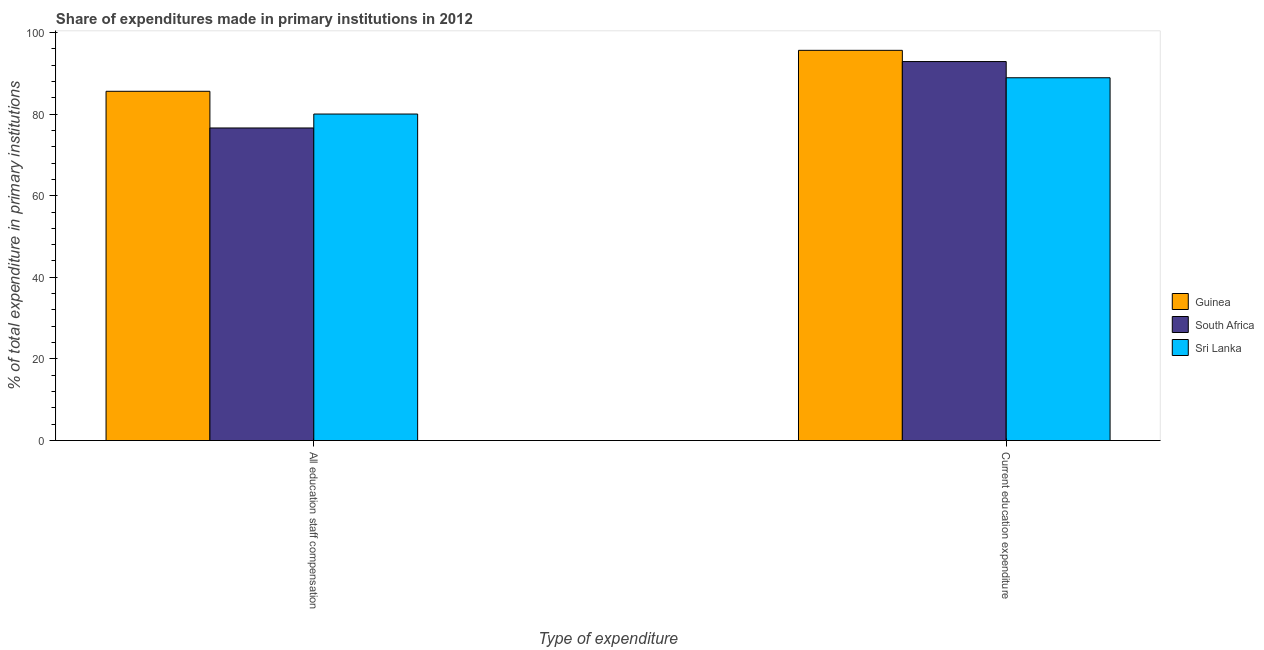How many different coloured bars are there?
Your answer should be very brief. 3. How many bars are there on the 2nd tick from the left?
Your answer should be compact. 3. What is the label of the 1st group of bars from the left?
Provide a succinct answer. All education staff compensation. What is the expenditure in education in Guinea?
Your answer should be compact. 95.61. Across all countries, what is the maximum expenditure in staff compensation?
Keep it short and to the point. 85.58. Across all countries, what is the minimum expenditure in education?
Provide a short and direct response. 88.89. In which country was the expenditure in education maximum?
Ensure brevity in your answer.  Guinea. In which country was the expenditure in staff compensation minimum?
Provide a short and direct response. South Africa. What is the total expenditure in education in the graph?
Your answer should be very brief. 277.37. What is the difference between the expenditure in staff compensation in Sri Lanka and that in Guinea?
Offer a terse response. -5.57. What is the difference between the expenditure in education in South Africa and the expenditure in staff compensation in Guinea?
Provide a succinct answer. 7.29. What is the average expenditure in staff compensation per country?
Make the answer very short. 80.72. What is the difference between the expenditure in staff compensation and expenditure in education in Sri Lanka?
Ensure brevity in your answer.  -8.89. What is the ratio of the expenditure in education in Sri Lanka to that in South Africa?
Keep it short and to the point. 0.96. Is the expenditure in staff compensation in Guinea less than that in South Africa?
Your answer should be compact. No. In how many countries, is the expenditure in staff compensation greater than the average expenditure in staff compensation taken over all countries?
Provide a short and direct response. 1. What does the 2nd bar from the left in Current education expenditure represents?
Offer a very short reply. South Africa. What does the 2nd bar from the right in Current education expenditure represents?
Your response must be concise. South Africa. How many countries are there in the graph?
Give a very brief answer. 3. Does the graph contain grids?
Your answer should be compact. No. How are the legend labels stacked?
Keep it short and to the point. Vertical. What is the title of the graph?
Ensure brevity in your answer.  Share of expenditures made in primary institutions in 2012. What is the label or title of the X-axis?
Your response must be concise. Type of expenditure. What is the label or title of the Y-axis?
Your answer should be compact. % of total expenditure in primary institutions. What is the % of total expenditure in primary institutions of Guinea in All education staff compensation?
Keep it short and to the point. 85.58. What is the % of total expenditure in primary institutions of South Africa in All education staff compensation?
Make the answer very short. 76.59. What is the % of total expenditure in primary institutions of Sri Lanka in All education staff compensation?
Provide a short and direct response. 80. What is the % of total expenditure in primary institutions of Guinea in Current education expenditure?
Keep it short and to the point. 95.61. What is the % of total expenditure in primary institutions of South Africa in Current education expenditure?
Your answer should be very brief. 92.86. What is the % of total expenditure in primary institutions of Sri Lanka in Current education expenditure?
Give a very brief answer. 88.89. Across all Type of expenditure, what is the maximum % of total expenditure in primary institutions of Guinea?
Provide a short and direct response. 95.61. Across all Type of expenditure, what is the maximum % of total expenditure in primary institutions of South Africa?
Keep it short and to the point. 92.86. Across all Type of expenditure, what is the maximum % of total expenditure in primary institutions in Sri Lanka?
Offer a very short reply. 88.89. Across all Type of expenditure, what is the minimum % of total expenditure in primary institutions in Guinea?
Give a very brief answer. 85.58. Across all Type of expenditure, what is the minimum % of total expenditure in primary institutions in South Africa?
Offer a terse response. 76.59. Across all Type of expenditure, what is the minimum % of total expenditure in primary institutions in Sri Lanka?
Provide a short and direct response. 80. What is the total % of total expenditure in primary institutions in Guinea in the graph?
Your answer should be very brief. 181.19. What is the total % of total expenditure in primary institutions in South Africa in the graph?
Ensure brevity in your answer.  169.45. What is the total % of total expenditure in primary institutions of Sri Lanka in the graph?
Ensure brevity in your answer.  168.9. What is the difference between the % of total expenditure in primary institutions of Guinea in All education staff compensation and that in Current education expenditure?
Your response must be concise. -10.04. What is the difference between the % of total expenditure in primary institutions of South Africa in All education staff compensation and that in Current education expenditure?
Make the answer very short. -16.27. What is the difference between the % of total expenditure in primary institutions of Sri Lanka in All education staff compensation and that in Current education expenditure?
Your response must be concise. -8.89. What is the difference between the % of total expenditure in primary institutions in Guinea in All education staff compensation and the % of total expenditure in primary institutions in South Africa in Current education expenditure?
Your answer should be compact. -7.29. What is the difference between the % of total expenditure in primary institutions in Guinea in All education staff compensation and the % of total expenditure in primary institutions in Sri Lanka in Current education expenditure?
Keep it short and to the point. -3.31. What is the difference between the % of total expenditure in primary institutions of South Africa in All education staff compensation and the % of total expenditure in primary institutions of Sri Lanka in Current education expenditure?
Your answer should be compact. -12.3. What is the average % of total expenditure in primary institutions of Guinea per Type of expenditure?
Ensure brevity in your answer.  90.6. What is the average % of total expenditure in primary institutions of South Africa per Type of expenditure?
Ensure brevity in your answer.  84.73. What is the average % of total expenditure in primary institutions of Sri Lanka per Type of expenditure?
Provide a short and direct response. 84.45. What is the difference between the % of total expenditure in primary institutions of Guinea and % of total expenditure in primary institutions of South Africa in All education staff compensation?
Your answer should be very brief. 8.99. What is the difference between the % of total expenditure in primary institutions in Guinea and % of total expenditure in primary institutions in Sri Lanka in All education staff compensation?
Give a very brief answer. 5.57. What is the difference between the % of total expenditure in primary institutions of South Africa and % of total expenditure in primary institutions of Sri Lanka in All education staff compensation?
Your answer should be very brief. -3.41. What is the difference between the % of total expenditure in primary institutions of Guinea and % of total expenditure in primary institutions of South Africa in Current education expenditure?
Provide a succinct answer. 2.75. What is the difference between the % of total expenditure in primary institutions of Guinea and % of total expenditure in primary institutions of Sri Lanka in Current education expenditure?
Your answer should be compact. 6.72. What is the difference between the % of total expenditure in primary institutions of South Africa and % of total expenditure in primary institutions of Sri Lanka in Current education expenditure?
Ensure brevity in your answer.  3.97. What is the ratio of the % of total expenditure in primary institutions of Guinea in All education staff compensation to that in Current education expenditure?
Your answer should be very brief. 0.9. What is the ratio of the % of total expenditure in primary institutions of South Africa in All education staff compensation to that in Current education expenditure?
Make the answer very short. 0.82. What is the difference between the highest and the second highest % of total expenditure in primary institutions of Guinea?
Make the answer very short. 10.04. What is the difference between the highest and the second highest % of total expenditure in primary institutions of South Africa?
Make the answer very short. 16.27. What is the difference between the highest and the second highest % of total expenditure in primary institutions of Sri Lanka?
Offer a terse response. 8.89. What is the difference between the highest and the lowest % of total expenditure in primary institutions in Guinea?
Provide a short and direct response. 10.04. What is the difference between the highest and the lowest % of total expenditure in primary institutions in South Africa?
Your response must be concise. 16.27. What is the difference between the highest and the lowest % of total expenditure in primary institutions of Sri Lanka?
Your response must be concise. 8.89. 